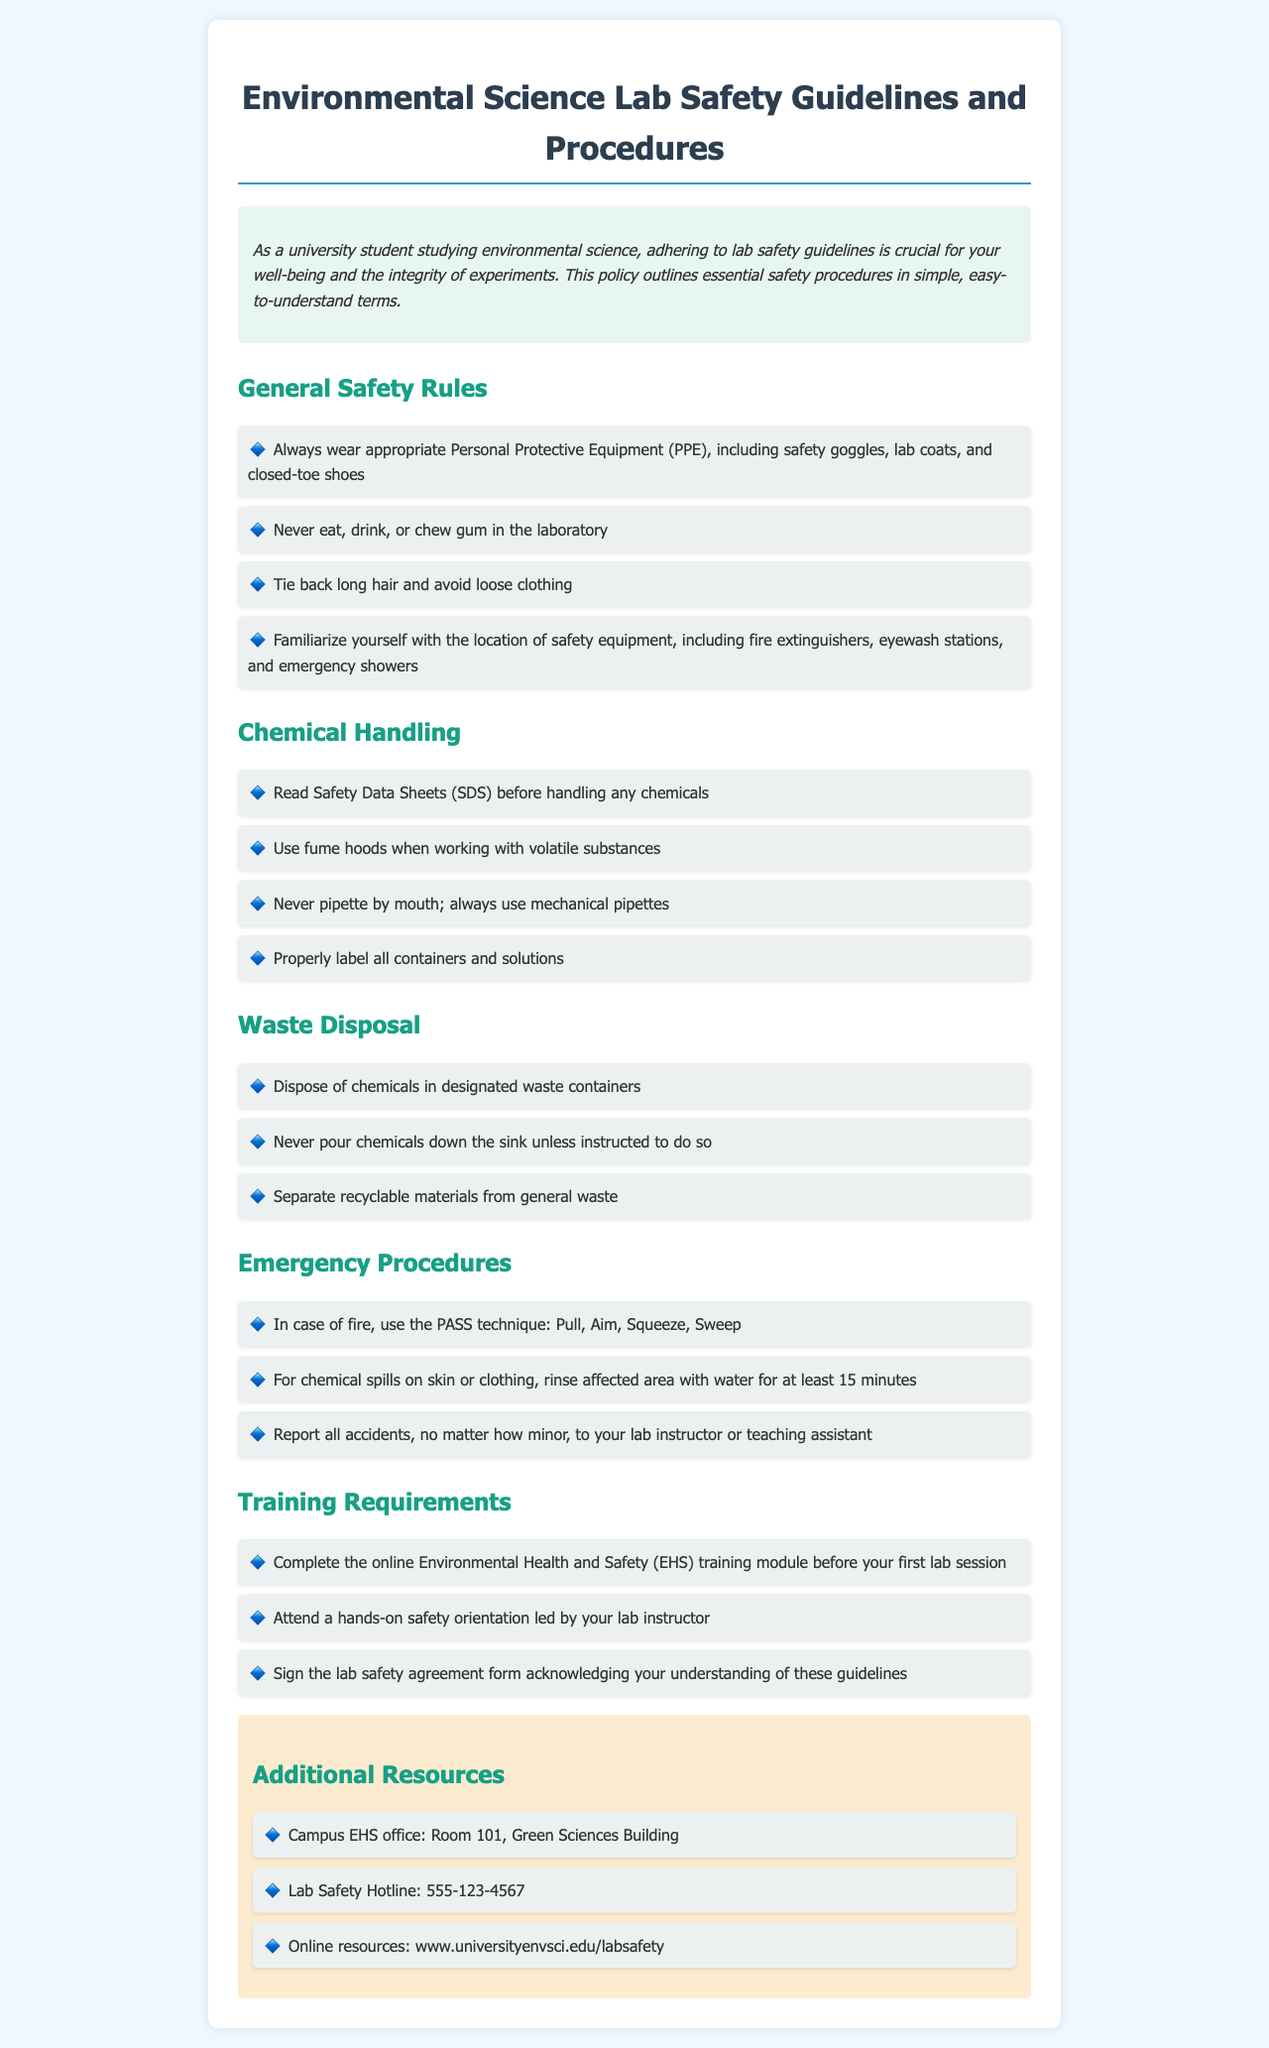What should be worn in the lab? The document states that appropriate Personal Protective Equipment (PPE) includes safety goggles, lab coats, and closed-toe shoes.
Answer: safety goggles, lab coats, closed-toe shoes What training module must be completed before the first lab session? The document specifies that students must complete the online Environmental Health and Safety (EHS) training module.
Answer: Environmental Health and Safety (EHS) How should chemicals be disposed of? The guidelines indicate that chemicals should be disposed of in designated waste containers.
Answer: designated waste containers What does PASS stand for in emergency procedures? The document lists the steps for using a fire extinguisher as Pull, Aim, Squeeze, Sweep, which is referred to as the PASS technique.
Answer: Pull, Aim, Squeeze, Sweep What is the emergency contact number for lab safety? The document provides the Lab Safety Hotline for emergencies, which is a specific number.
Answer: 555-123-4567 